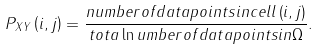Convert formula to latex. <formula><loc_0><loc_0><loc_500><loc_500>P _ { X Y } \left ( i , j \right ) = \frac { n u m b e r o f d a t a p o i n t s i n c e l l \left ( i , j \right ) } { t o t a \ln u m b e r o f d a t a p o i n t s i n \Omega } .</formula> 